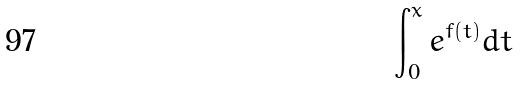Convert formula to latex. <formula><loc_0><loc_0><loc_500><loc_500>\int _ { 0 } ^ { x } e ^ { f ( t ) } d t</formula> 